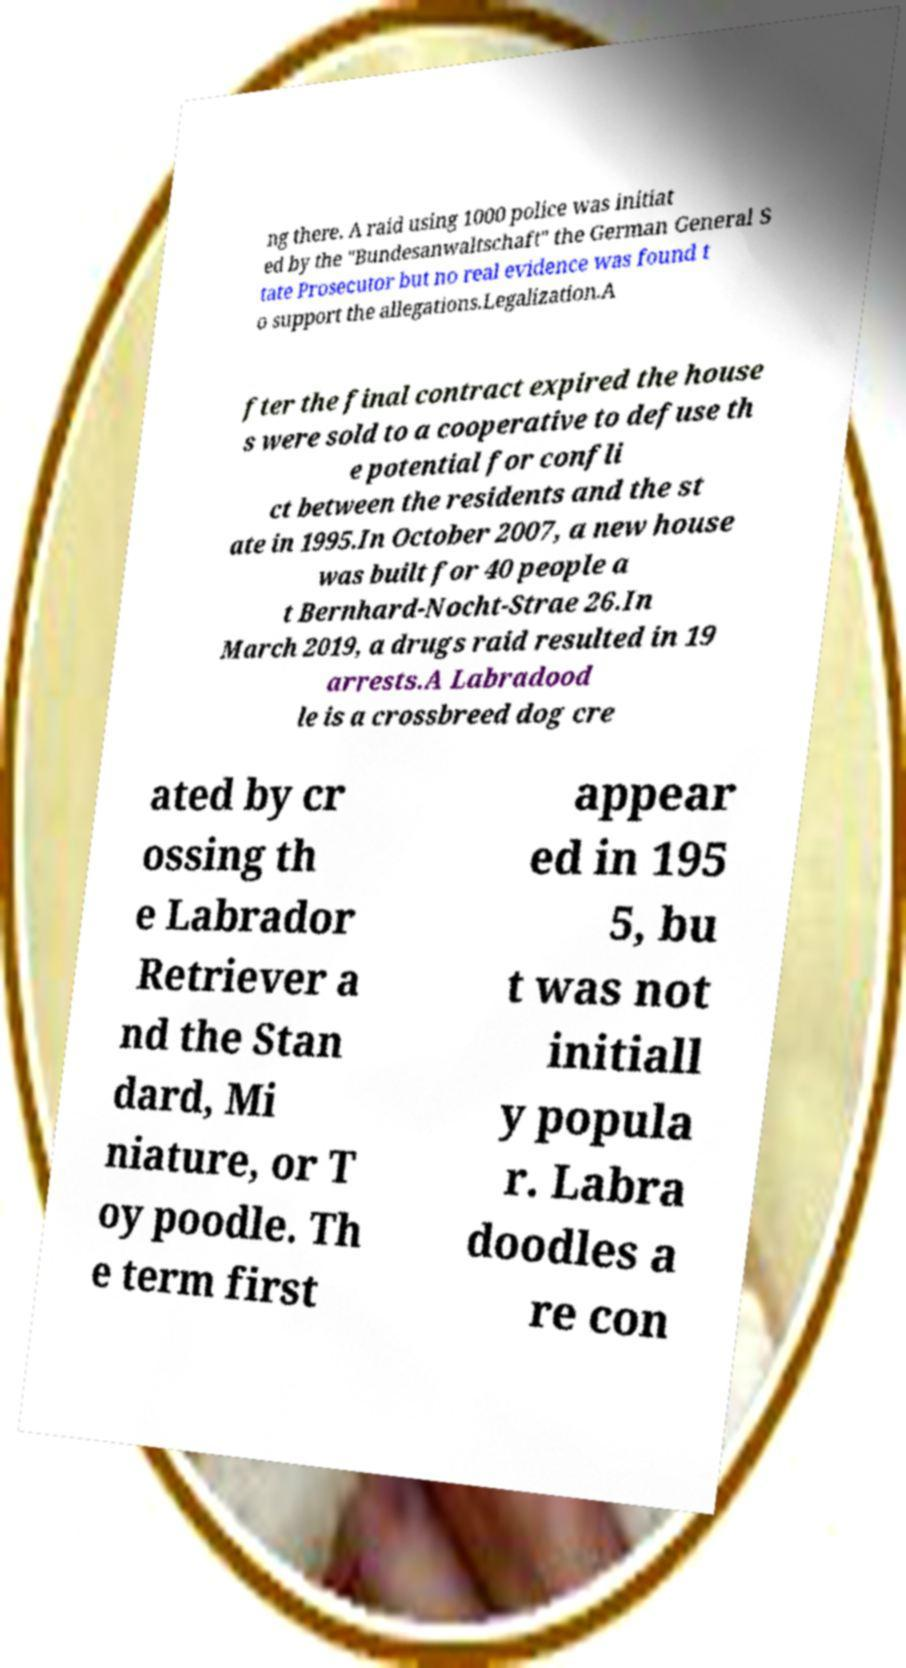Could you assist in decoding the text presented in this image and type it out clearly? ng there. A raid using 1000 police was initiat ed by the "Bundesanwaltschaft" the German General S tate Prosecutor but no real evidence was found t o support the allegations.Legalization.A fter the final contract expired the house s were sold to a cooperative to defuse th e potential for confli ct between the residents and the st ate in 1995.In October 2007, a new house was built for 40 people a t Bernhard-Nocht-Strae 26.In March 2019, a drugs raid resulted in 19 arrests.A Labradood le is a crossbreed dog cre ated by cr ossing th e Labrador Retriever a nd the Stan dard, Mi niature, or T oy poodle. Th e term first appear ed in 195 5, bu t was not initiall y popula r. Labra doodles a re con 